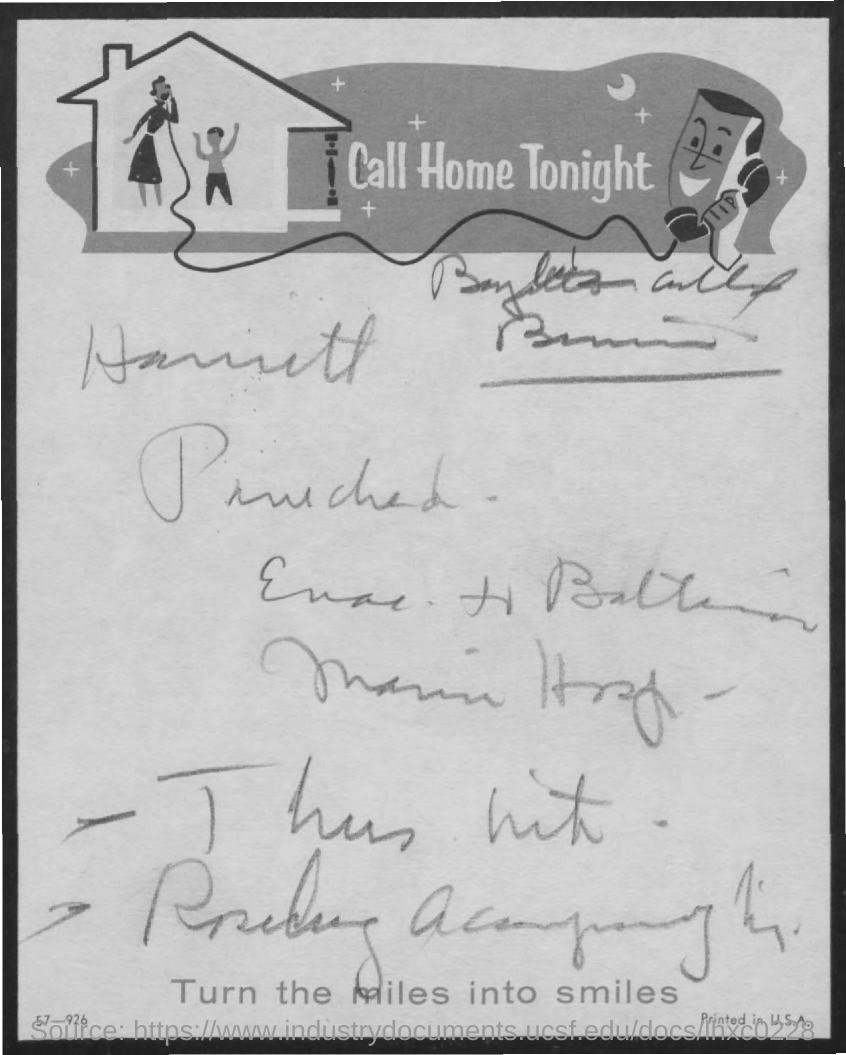Mention a couple of crucial points in this snapshot. The title at the bottom of the document is 'turn the miles into smiles.' 